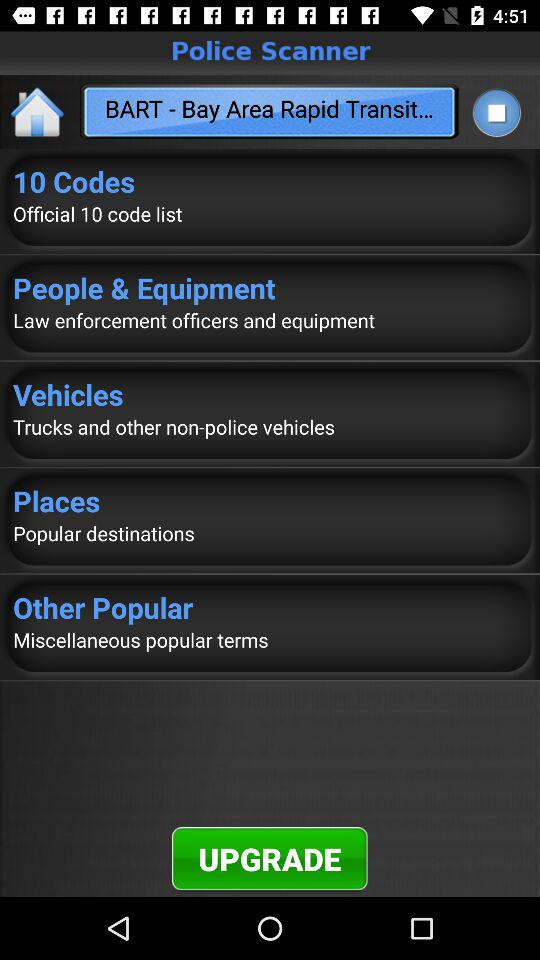What is the number of code list in 10 code folder?
When the provided information is insufficient, respond with <no answer>. <no answer> 